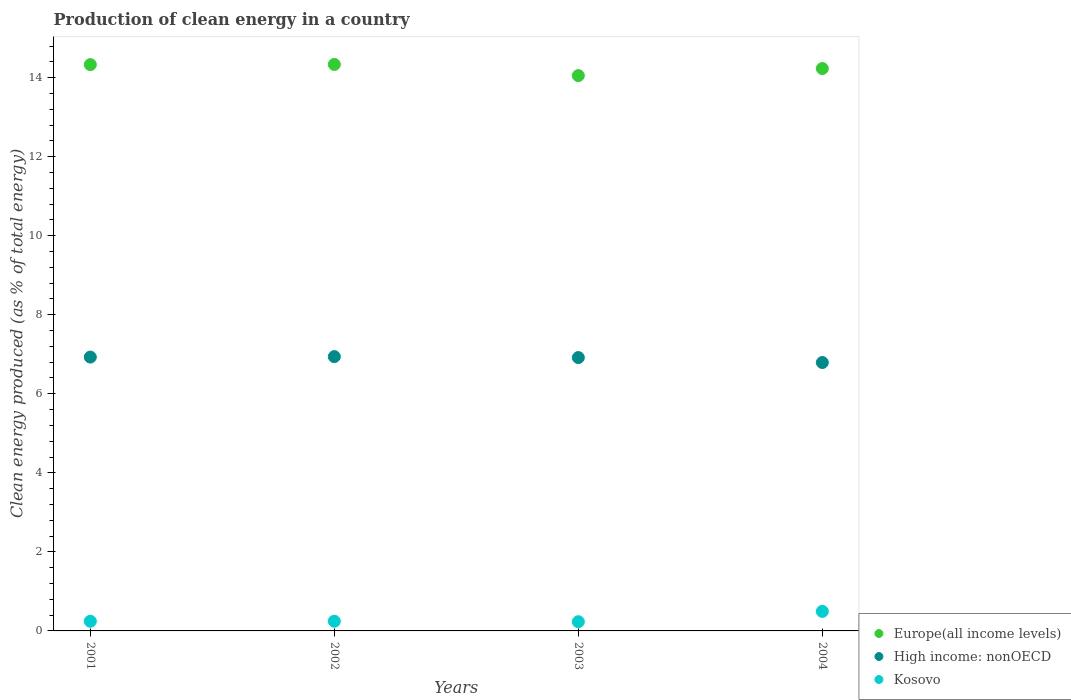How many different coloured dotlines are there?
Give a very brief answer. 3. What is the percentage of clean energy produced in Kosovo in 2001?
Ensure brevity in your answer.  0.24. Across all years, what is the maximum percentage of clean energy produced in High income: nonOECD?
Provide a short and direct response. 6.94. Across all years, what is the minimum percentage of clean energy produced in Kosovo?
Keep it short and to the point. 0.23. What is the total percentage of clean energy produced in Europe(all income levels) in the graph?
Ensure brevity in your answer.  56.94. What is the difference between the percentage of clean energy produced in High income: nonOECD in 2001 and that in 2003?
Provide a short and direct response. 0.01. What is the difference between the percentage of clean energy produced in Kosovo in 2004 and the percentage of clean energy produced in High income: nonOECD in 2003?
Give a very brief answer. -6.42. What is the average percentage of clean energy produced in High income: nonOECD per year?
Provide a succinct answer. 6.89. In the year 2002, what is the difference between the percentage of clean energy produced in Europe(all income levels) and percentage of clean energy produced in Kosovo?
Offer a terse response. 14.09. In how many years, is the percentage of clean energy produced in High income: nonOECD greater than 2 %?
Keep it short and to the point. 4. What is the ratio of the percentage of clean energy produced in Europe(all income levels) in 2002 to that in 2004?
Make the answer very short. 1.01. What is the difference between the highest and the second highest percentage of clean energy produced in High income: nonOECD?
Ensure brevity in your answer.  0.01. What is the difference between the highest and the lowest percentage of clean energy produced in Kosovo?
Ensure brevity in your answer.  0.26. Is the sum of the percentage of clean energy produced in Kosovo in 2002 and 2003 greater than the maximum percentage of clean energy produced in Europe(all income levels) across all years?
Provide a short and direct response. No. Does the percentage of clean energy produced in Europe(all income levels) monotonically increase over the years?
Keep it short and to the point. No. How many dotlines are there?
Your answer should be compact. 3. How many years are there in the graph?
Offer a terse response. 4. What is the difference between two consecutive major ticks on the Y-axis?
Your response must be concise. 2. Does the graph contain any zero values?
Offer a terse response. No. Does the graph contain grids?
Your response must be concise. No. What is the title of the graph?
Provide a short and direct response. Production of clean energy in a country. Does "Kyrgyz Republic" appear as one of the legend labels in the graph?
Your response must be concise. No. What is the label or title of the Y-axis?
Provide a short and direct response. Clean energy produced (as % of total energy). What is the Clean energy produced (as % of total energy) of Europe(all income levels) in 2001?
Provide a succinct answer. 14.33. What is the Clean energy produced (as % of total energy) in High income: nonOECD in 2001?
Your answer should be compact. 6.93. What is the Clean energy produced (as % of total energy) of Kosovo in 2001?
Keep it short and to the point. 0.24. What is the Clean energy produced (as % of total energy) of Europe(all income levels) in 2002?
Offer a very short reply. 14.33. What is the Clean energy produced (as % of total energy) in High income: nonOECD in 2002?
Ensure brevity in your answer.  6.94. What is the Clean energy produced (as % of total energy) of Kosovo in 2002?
Keep it short and to the point. 0.24. What is the Clean energy produced (as % of total energy) of Europe(all income levels) in 2003?
Make the answer very short. 14.05. What is the Clean energy produced (as % of total energy) of High income: nonOECD in 2003?
Your response must be concise. 6.92. What is the Clean energy produced (as % of total energy) in Kosovo in 2003?
Give a very brief answer. 0.23. What is the Clean energy produced (as % of total energy) of Europe(all income levels) in 2004?
Offer a terse response. 14.23. What is the Clean energy produced (as % of total energy) in High income: nonOECD in 2004?
Offer a very short reply. 6.79. What is the Clean energy produced (as % of total energy) of Kosovo in 2004?
Provide a succinct answer. 0.49. Across all years, what is the maximum Clean energy produced (as % of total energy) of Europe(all income levels)?
Your answer should be very brief. 14.33. Across all years, what is the maximum Clean energy produced (as % of total energy) of High income: nonOECD?
Provide a succinct answer. 6.94. Across all years, what is the maximum Clean energy produced (as % of total energy) in Kosovo?
Your answer should be very brief. 0.49. Across all years, what is the minimum Clean energy produced (as % of total energy) of Europe(all income levels)?
Your answer should be very brief. 14.05. Across all years, what is the minimum Clean energy produced (as % of total energy) of High income: nonOECD?
Provide a short and direct response. 6.79. Across all years, what is the minimum Clean energy produced (as % of total energy) in Kosovo?
Ensure brevity in your answer.  0.23. What is the total Clean energy produced (as % of total energy) in Europe(all income levels) in the graph?
Provide a succinct answer. 56.94. What is the total Clean energy produced (as % of total energy) of High income: nonOECD in the graph?
Provide a succinct answer. 27.58. What is the total Clean energy produced (as % of total energy) of Kosovo in the graph?
Your response must be concise. 1.22. What is the difference between the Clean energy produced (as % of total energy) in Europe(all income levels) in 2001 and that in 2002?
Offer a very short reply. -0. What is the difference between the Clean energy produced (as % of total energy) of High income: nonOECD in 2001 and that in 2002?
Provide a short and direct response. -0.01. What is the difference between the Clean energy produced (as % of total energy) of Kosovo in 2001 and that in 2002?
Offer a very short reply. -0. What is the difference between the Clean energy produced (as % of total energy) in Europe(all income levels) in 2001 and that in 2003?
Your response must be concise. 0.28. What is the difference between the Clean energy produced (as % of total energy) of High income: nonOECD in 2001 and that in 2003?
Ensure brevity in your answer.  0.01. What is the difference between the Clean energy produced (as % of total energy) in Kosovo in 2001 and that in 2003?
Provide a succinct answer. 0.01. What is the difference between the Clean energy produced (as % of total energy) in Europe(all income levels) in 2001 and that in 2004?
Ensure brevity in your answer.  0.1. What is the difference between the Clean energy produced (as % of total energy) of High income: nonOECD in 2001 and that in 2004?
Your answer should be very brief. 0.14. What is the difference between the Clean energy produced (as % of total energy) in Kosovo in 2001 and that in 2004?
Your response must be concise. -0.25. What is the difference between the Clean energy produced (as % of total energy) of Europe(all income levels) in 2002 and that in 2003?
Give a very brief answer. 0.28. What is the difference between the Clean energy produced (as % of total energy) in High income: nonOECD in 2002 and that in 2003?
Provide a short and direct response. 0.02. What is the difference between the Clean energy produced (as % of total energy) of Kosovo in 2002 and that in 2003?
Give a very brief answer. 0.01. What is the difference between the Clean energy produced (as % of total energy) of Europe(all income levels) in 2002 and that in 2004?
Keep it short and to the point. 0.1. What is the difference between the Clean energy produced (as % of total energy) of High income: nonOECD in 2002 and that in 2004?
Your answer should be compact. 0.15. What is the difference between the Clean energy produced (as % of total energy) of Kosovo in 2002 and that in 2004?
Offer a terse response. -0.25. What is the difference between the Clean energy produced (as % of total energy) in Europe(all income levels) in 2003 and that in 2004?
Offer a very short reply. -0.18. What is the difference between the Clean energy produced (as % of total energy) in High income: nonOECD in 2003 and that in 2004?
Offer a very short reply. 0.13. What is the difference between the Clean energy produced (as % of total energy) of Kosovo in 2003 and that in 2004?
Give a very brief answer. -0.26. What is the difference between the Clean energy produced (as % of total energy) in Europe(all income levels) in 2001 and the Clean energy produced (as % of total energy) in High income: nonOECD in 2002?
Your response must be concise. 7.39. What is the difference between the Clean energy produced (as % of total energy) in Europe(all income levels) in 2001 and the Clean energy produced (as % of total energy) in Kosovo in 2002?
Keep it short and to the point. 14.08. What is the difference between the Clean energy produced (as % of total energy) in High income: nonOECD in 2001 and the Clean energy produced (as % of total energy) in Kosovo in 2002?
Keep it short and to the point. 6.68. What is the difference between the Clean energy produced (as % of total energy) in Europe(all income levels) in 2001 and the Clean energy produced (as % of total energy) in High income: nonOECD in 2003?
Offer a terse response. 7.41. What is the difference between the Clean energy produced (as % of total energy) of Europe(all income levels) in 2001 and the Clean energy produced (as % of total energy) of Kosovo in 2003?
Provide a short and direct response. 14.1. What is the difference between the Clean energy produced (as % of total energy) in High income: nonOECD in 2001 and the Clean energy produced (as % of total energy) in Kosovo in 2003?
Give a very brief answer. 6.7. What is the difference between the Clean energy produced (as % of total energy) of Europe(all income levels) in 2001 and the Clean energy produced (as % of total energy) of High income: nonOECD in 2004?
Your answer should be compact. 7.54. What is the difference between the Clean energy produced (as % of total energy) of Europe(all income levels) in 2001 and the Clean energy produced (as % of total energy) of Kosovo in 2004?
Your answer should be compact. 13.83. What is the difference between the Clean energy produced (as % of total energy) in High income: nonOECD in 2001 and the Clean energy produced (as % of total energy) in Kosovo in 2004?
Make the answer very short. 6.43. What is the difference between the Clean energy produced (as % of total energy) in Europe(all income levels) in 2002 and the Clean energy produced (as % of total energy) in High income: nonOECD in 2003?
Offer a terse response. 7.42. What is the difference between the Clean energy produced (as % of total energy) in Europe(all income levels) in 2002 and the Clean energy produced (as % of total energy) in Kosovo in 2003?
Offer a terse response. 14.1. What is the difference between the Clean energy produced (as % of total energy) of High income: nonOECD in 2002 and the Clean energy produced (as % of total energy) of Kosovo in 2003?
Make the answer very short. 6.71. What is the difference between the Clean energy produced (as % of total energy) of Europe(all income levels) in 2002 and the Clean energy produced (as % of total energy) of High income: nonOECD in 2004?
Make the answer very short. 7.54. What is the difference between the Clean energy produced (as % of total energy) of Europe(all income levels) in 2002 and the Clean energy produced (as % of total energy) of Kosovo in 2004?
Make the answer very short. 13.84. What is the difference between the Clean energy produced (as % of total energy) in High income: nonOECD in 2002 and the Clean energy produced (as % of total energy) in Kosovo in 2004?
Your response must be concise. 6.45. What is the difference between the Clean energy produced (as % of total energy) in Europe(all income levels) in 2003 and the Clean energy produced (as % of total energy) in High income: nonOECD in 2004?
Offer a terse response. 7.26. What is the difference between the Clean energy produced (as % of total energy) of Europe(all income levels) in 2003 and the Clean energy produced (as % of total energy) of Kosovo in 2004?
Keep it short and to the point. 13.56. What is the difference between the Clean energy produced (as % of total energy) of High income: nonOECD in 2003 and the Clean energy produced (as % of total energy) of Kosovo in 2004?
Your response must be concise. 6.42. What is the average Clean energy produced (as % of total energy) of Europe(all income levels) per year?
Give a very brief answer. 14.24. What is the average Clean energy produced (as % of total energy) in High income: nonOECD per year?
Your response must be concise. 6.89. What is the average Clean energy produced (as % of total energy) of Kosovo per year?
Make the answer very short. 0.3. In the year 2001, what is the difference between the Clean energy produced (as % of total energy) of Europe(all income levels) and Clean energy produced (as % of total energy) of High income: nonOECD?
Ensure brevity in your answer.  7.4. In the year 2001, what is the difference between the Clean energy produced (as % of total energy) in Europe(all income levels) and Clean energy produced (as % of total energy) in Kosovo?
Make the answer very short. 14.09. In the year 2001, what is the difference between the Clean energy produced (as % of total energy) in High income: nonOECD and Clean energy produced (as % of total energy) in Kosovo?
Give a very brief answer. 6.68. In the year 2002, what is the difference between the Clean energy produced (as % of total energy) of Europe(all income levels) and Clean energy produced (as % of total energy) of High income: nonOECD?
Give a very brief answer. 7.39. In the year 2002, what is the difference between the Clean energy produced (as % of total energy) of Europe(all income levels) and Clean energy produced (as % of total energy) of Kosovo?
Offer a terse response. 14.09. In the year 2002, what is the difference between the Clean energy produced (as % of total energy) in High income: nonOECD and Clean energy produced (as % of total energy) in Kosovo?
Offer a terse response. 6.7. In the year 2003, what is the difference between the Clean energy produced (as % of total energy) of Europe(all income levels) and Clean energy produced (as % of total energy) of High income: nonOECD?
Provide a short and direct response. 7.13. In the year 2003, what is the difference between the Clean energy produced (as % of total energy) in Europe(all income levels) and Clean energy produced (as % of total energy) in Kosovo?
Your answer should be very brief. 13.82. In the year 2003, what is the difference between the Clean energy produced (as % of total energy) in High income: nonOECD and Clean energy produced (as % of total energy) in Kosovo?
Provide a short and direct response. 6.68. In the year 2004, what is the difference between the Clean energy produced (as % of total energy) of Europe(all income levels) and Clean energy produced (as % of total energy) of High income: nonOECD?
Your response must be concise. 7.44. In the year 2004, what is the difference between the Clean energy produced (as % of total energy) of Europe(all income levels) and Clean energy produced (as % of total energy) of Kosovo?
Offer a terse response. 13.74. In the year 2004, what is the difference between the Clean energy produced (as % of total energy) in High income: nonOECD and Clean energy produced (as % of total energy) in Kosovo?
Provide a succinct answer. 6.3. What is the ratio of the Clean energy produced (as % of total energy) of High income: nonOECD in 2001 to that in 2002?
Make the answer very short. 1. What is the ratio of the Clean energy produced (as % of total energy) in Kosovo in 2001 to that in 2002?
Offer a very short reply. 1. What is the ratio of the Clean energy produced (as % of total energy) in Europe(all income levels) in 2001 to that in 2003?
Your answer should be very brief. 1.02. What is the ratio of the Clean energy produced (as % of total energy) of Kosovo in 2001 to that in 2003?
Give a very brief answer. 1.05. What is the ratio of the Clean energy produced (as % of total energy) of Europe(all income levels) in 2001 to that in 2004?
Keep it short and to the point. 1.01. What is the ratio of the Clean energy produced (as % of total energy) of High income: nonOECD in 2001 to that in 2004?
Provide a succinct answer. 1.02. What is the ratio of the Clean energy produced (as % of total energy) in Kosovo in 2001 to that in 2004?
Your response must be concise. 0.49. What is the ratio of the Clean energy produced (as % of total energy) of Europe(all income levels) in 2002 to that in 2003?
Provide a succinct answer. 1.02. What is the ratio of the Clean energy produced (as % of total energy) in High income: nonOECD in 2002 to that in 2003?
Make the answer very short. 1. What is the ratio of the Clean energy produced (as % of total energy) of Kosovo in 2002 to that in 2003?
Provide a succinct answer. 1.05. What is the ratio of the Clean energy produced (as % of total energy) in Europe(all income levels) in 2002 to that in 2004?
Give a very brief answer. 1.01. What is the ratio of the Clean energy produced (as % of total energy) in High income: nonOECD in 2002 to that in 2004?
Give a very brief answer. 1.02. What is the ratio of the Clean energy produced (as % of total energy) in Kosovo in 2002 to that in 2004?
Provide a short and direct response. 0.5. What is the ratio of the Clean energy produced (as % of total energy) in Europe(all income levels) in 2003 to that in 2004?
Keep it short and to the point. 0.99. What is the ratio of the Clean energy produced (as % of total energy) of High income: nonOECD in 2003 to that in 2004?
Make the answer very short. 1.02. What is the ratio of the Clean energy produced (as % of total energy) in Kosovo in 2003 to that in 2004?
Provide a succinct answer. 0.47. What is the difference between the highest and the second highest Clean energy produced (as % of total energy) in Europe(all income levels)?
Ensure brevity in your answer.  0. What is the difference between the highest and the second highest Clean energy produced (as % of total energy) in High income: nonOECD?
Your answer should be very brief. 0.01. What is the difference between the highest and the second highest Clean energy produced (as % of total energy) of Kosovo?
Your response must be concise. 0.25. What is the difference between the highest and the lowest Clean energy produced (as % of total energy) in Europe(all income levels)?
Give a very brief answer. 0.28. What is the difference between the highest and the lowest Clean energy produced (as % of total energy) in High income: nonOECD?
Your answer should be very brief. 0.15. What is the difference between the highest and the lowest Clean energy produced (as % of total energy) of Kosovo?
Provide a succinct answer. 0.26. 